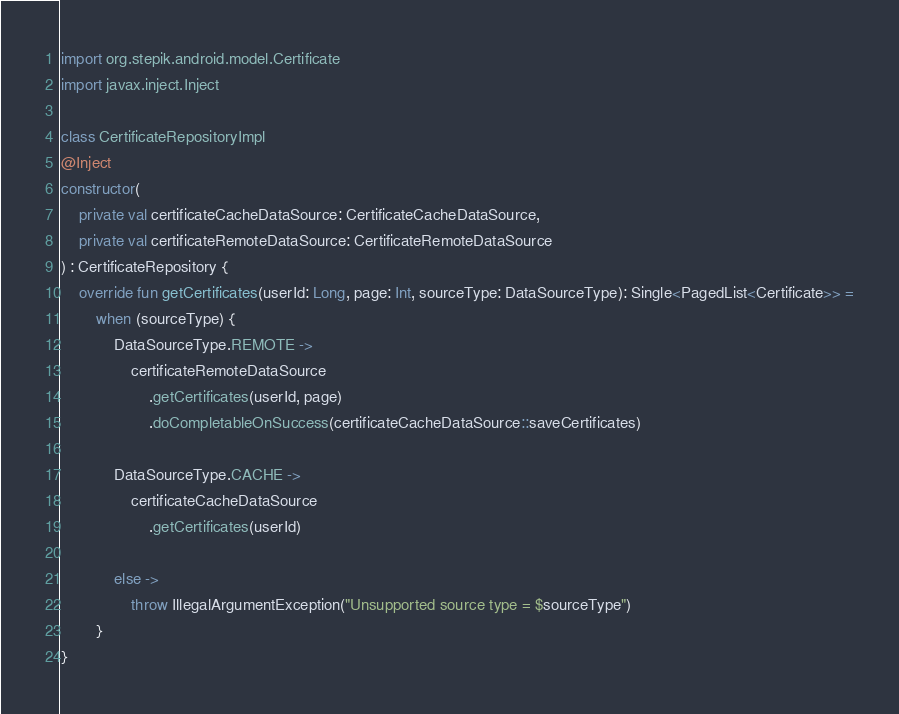<code> <loc_0><loc_0><loc_500><loc_500><_Kotlin_>import org.stepik.android.model.Certificate
import javax.inject.Inject

class CertificateRepositoryImpl
@Inject
constructor(
    private val certificateCacheDataSource: CertificateCacheDataSource,
    private val certificateRemoteDataSource: CertificateRemoteDataSource
) : CertificateRepository {
    override fun getCertificates(userId: Long, page: Int, sourceType: DataSourceType): Single<PagedList<Certificate>> =
        when (sourceType) {
            DataSourceType.REMOTE ->
                certificateRemoteDataSource
                    .getCertificates(userId, page)
                    .doCompletableOnSuccess(certificateCacheDataSource::saveCertificates)

            DataSourceType.CACHE ->
                certificateCacheDataSource
                    .getCertificates(userId)

            else ->
                throw IllegalArgumentException("Unsupported source type = $sourceType")
        }
}</code> 